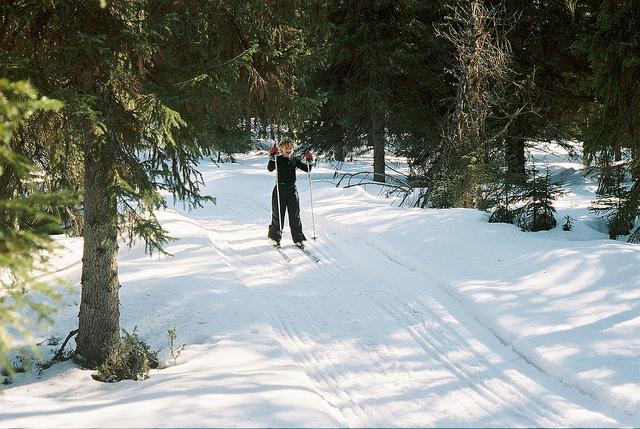What color are the lines in the snow?
Be succinct. White. What is on the tree to the left of the picture?
Write a very short answer. Snow. Will these skiers make it back before the sun goes down?
Keep it brief. Yes. Is she skiing downhill?
Be succinct. Yes. How many tracks can be seen in the snow?
Keep it brief. 2. If this person fell on their head, would their hair get wet?
Give a very brief answer. Yes. What is the woman holding?
Give a very brief answer. Ski poles. What type of skiing is this?
Answer briefly. Cross country. What covers the bushes?
Keep it brief. Snow. How many skiers are pictured?
Short answer required. 1. What type of trees are present in this picture?
Be succinct. Pine. 